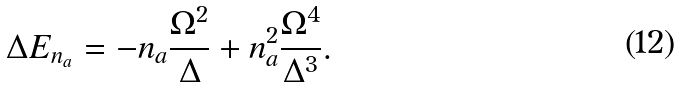Convert formula to latex. <formula><loc_0><loc_0><loc_500><loc_500>\Delta E _ { n _ { a } } = - n _ { a } \frac { \Omega ^ { 2 } } { \Delta } + n _ { a } ^ { 2 } \frac { \Omega ^ { 4 } } { \Delta ^ { 3 } } .</formula> 